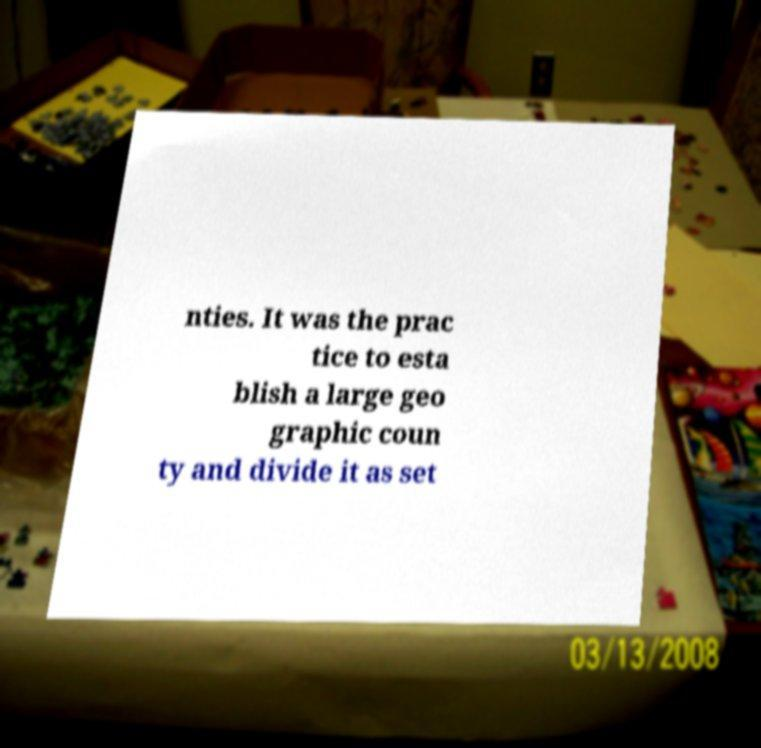Please read and relay the text visible in this image. What does it say? nties. It was the prac tice to esta blish a large geo graphic coun ty and divide it as set 